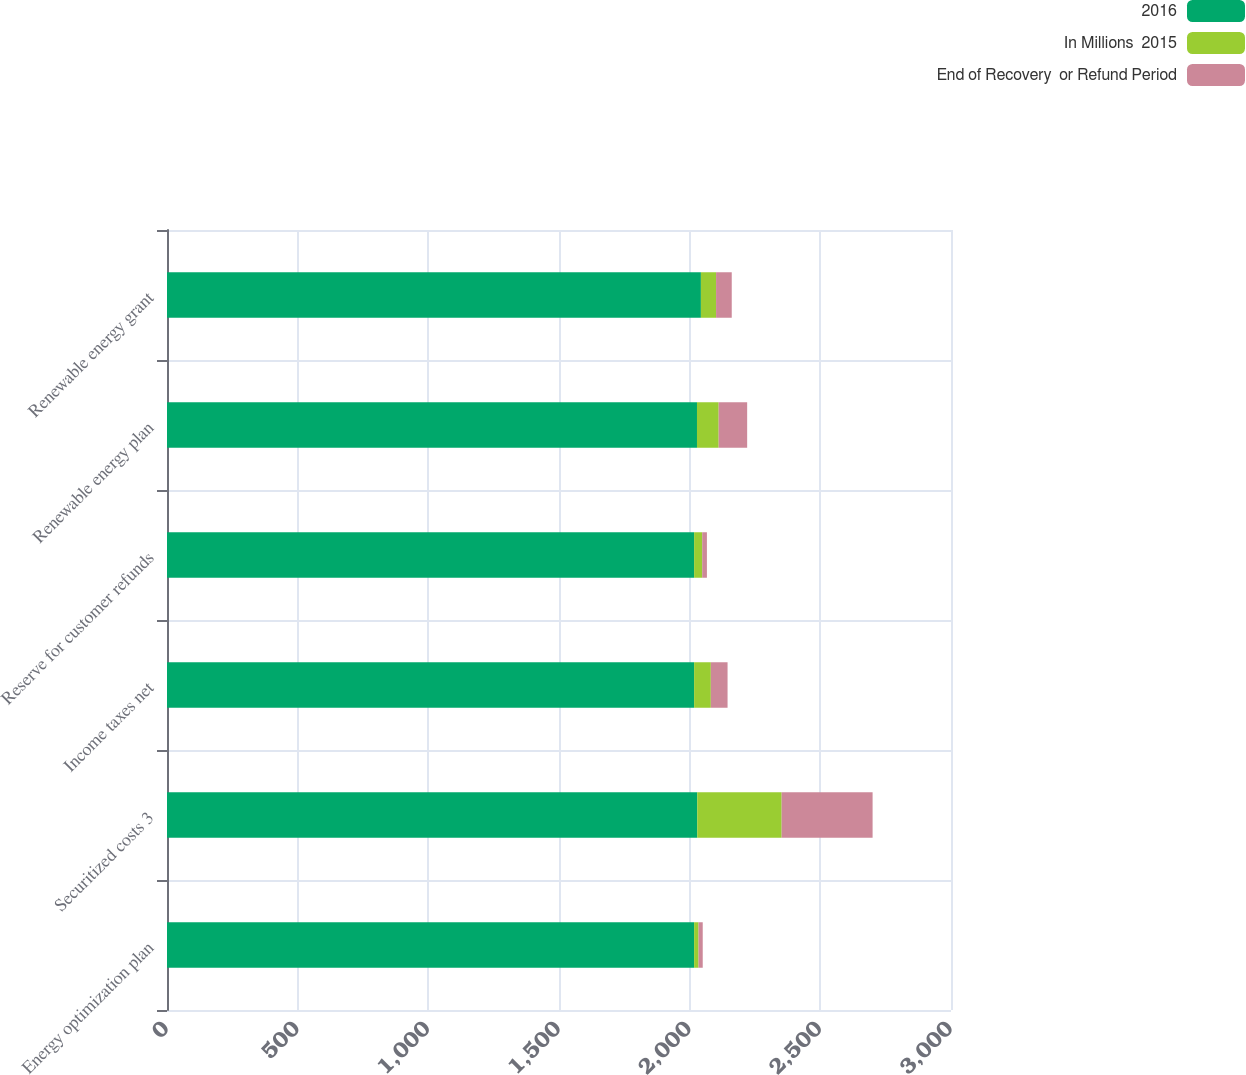<chart> <loc_0><loc_0><loc_500><loc_500><stacked_bar_chart><ecel><fcel>Energy optimization plan<fcel>Securitized costs 3<fcel>Income taxes net<fcel>Reserve for customer refunds<fcel>Renewable energy plan<fcel>Renewable energy grant<nl><fcel>2016<fcel>2017<fcel>2029<fcel>2017<fcel>2017<fcel>2028<fcel>2043<nl><fcel>In Millions  2015<fcel>17<fcel>323<fcel>64<fcel>31<fcel>83<fcel>58<nl><fcel>End of Recovery  or Refund Period<fcel>16<fcel>348<fcel>64<fcel>18<fcel>109<fcel>60<nl></chart> 